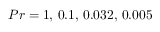Convert formula to latex. <formula><loc_0><loc_0><loc_500><loc_500>P r = 1 , \, 0 . 1 , \, 0 . 0 3 2 , \, 0 . 0 0 5</formula> 